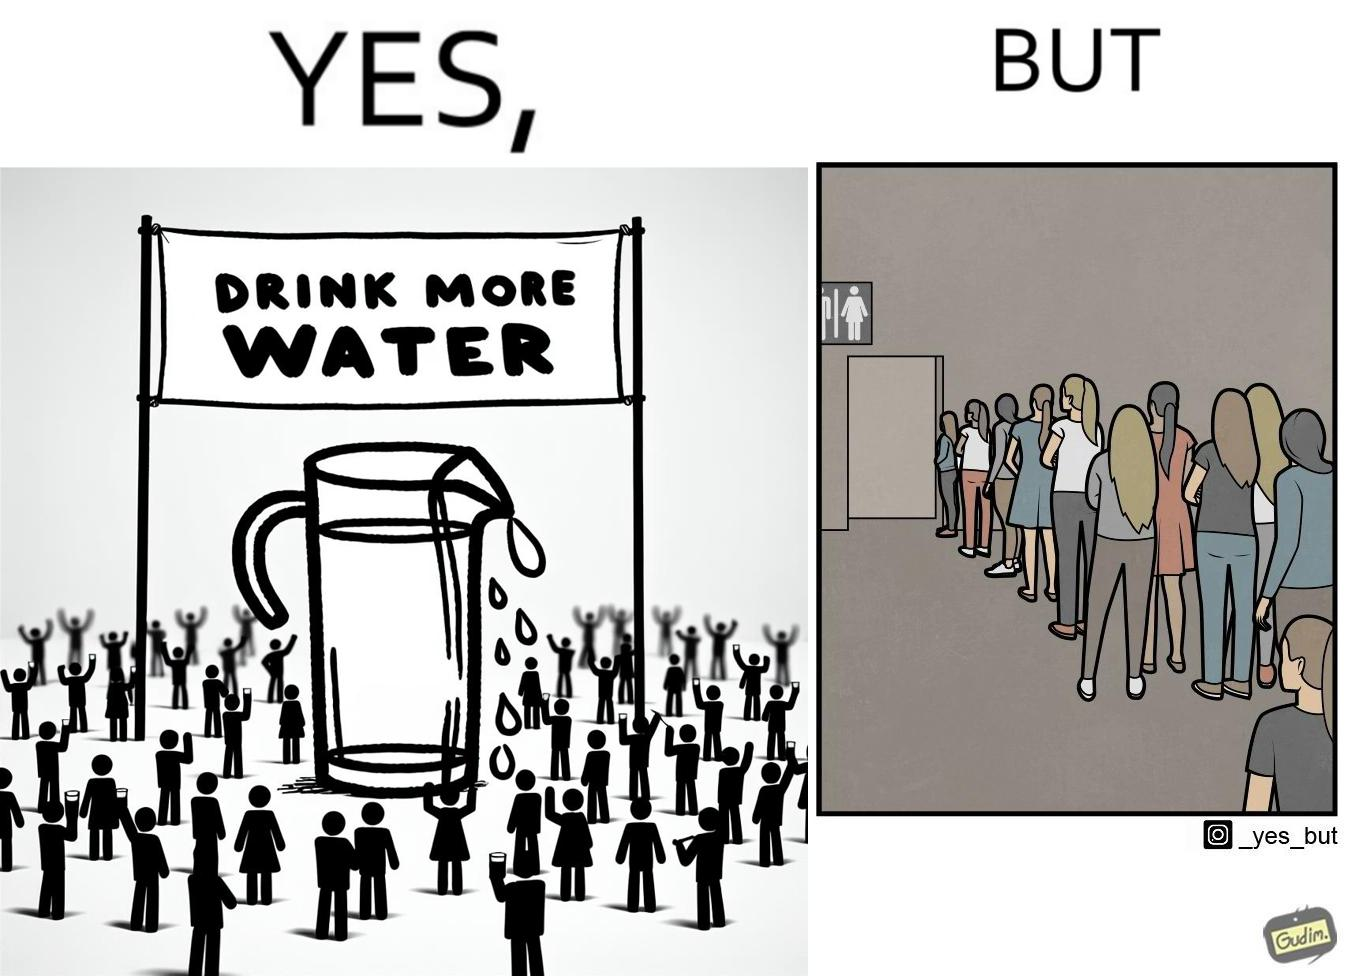Describe what you see in this image. The image is ironical, as the message "Drink more water" is meant to improve health, but in turn, it would lead to longer queues in front of public toilets, leading to people holding urine for longer periods, in turn leading to deterioration in health. 